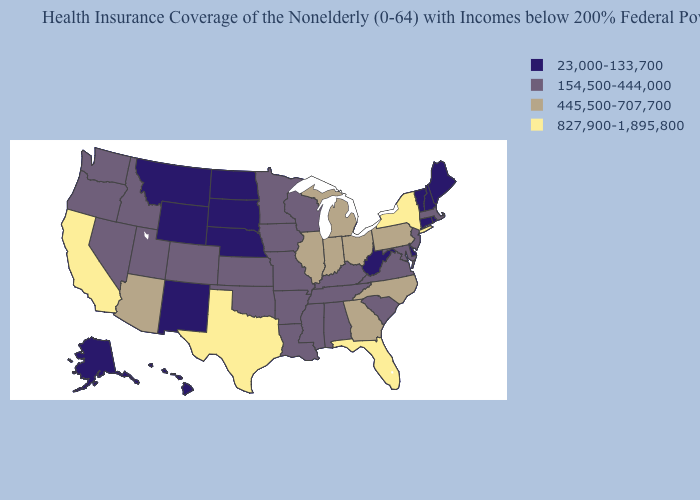What is the value of Washington?
Be succinct. 154,500-444,000. Does North Carolina have a lower value than North Dakota?
Be succinct. No. Does the first symbol in the legend represent the smallest category?
Concise answer only. Yes. Name the states that have a value in the range 23,000-133,700?
Be succinct. Alaska, Connecticut, Delaware, Hawaii, Maine, Montana, Nebraska, New Hampshire, New Mexico, North Dakota, Rhode Island, South Dakota, Vermont, West Virginia, Wyoming. Does South Dakota have the same value as Connecticut?
Write a very short answer. Yes. Name the states that have a value in the range 23,000-133,700?
Concise answer only. Alaska, Connecticut, Delaware, Hawaii, Maine, Montana, Nebraska, New Hampshire, New Mexico, North Dakota, Rhode Island, South Dakota, Vermont, West Virginia, Wyoming. What is the value of Florida?
Be succinct. 827,900-1,895,800. What is the value of California?
Quick response, please. 827,900-1,895,800. Name the states that have a value in the range 23,000-133,700?
Keep it brief. Alaska, Connecticut, Delaware, Hawaii, Maine, Montana, Nebraska, New Hampshire, New Mexico, North Dakota, Rhode Island, South Dakota, Vermont, West Virginia, Wyoming. Does Georgia have a lower value than Hawaii?
Give a very brief answer. No. What is the highest value in the West ?
Give a very brief answer. 827,900-1,895,800. Name the states that have a value in the range 154,500-444,000?
Concise answer only. Alabama, Arkansas, Colorado, Idaho, Iowa, Kansas, Kentucky, Louisiana, Maryland, Massachusetts, Minnesota, Mississippi, Missouri, Nevada, New Jersey, Oklahoma, Oregon, South Carolina, Tennessee, Utah, Virginia, Washington, Wisconsin. What is the highest value in the South ?
Concise answer only. 827,900-1,895,800. What is the value of Maryland?
Answer briefly. 154,500-444,000. How many symbols are there in the legend?
Be succinct. 4. 